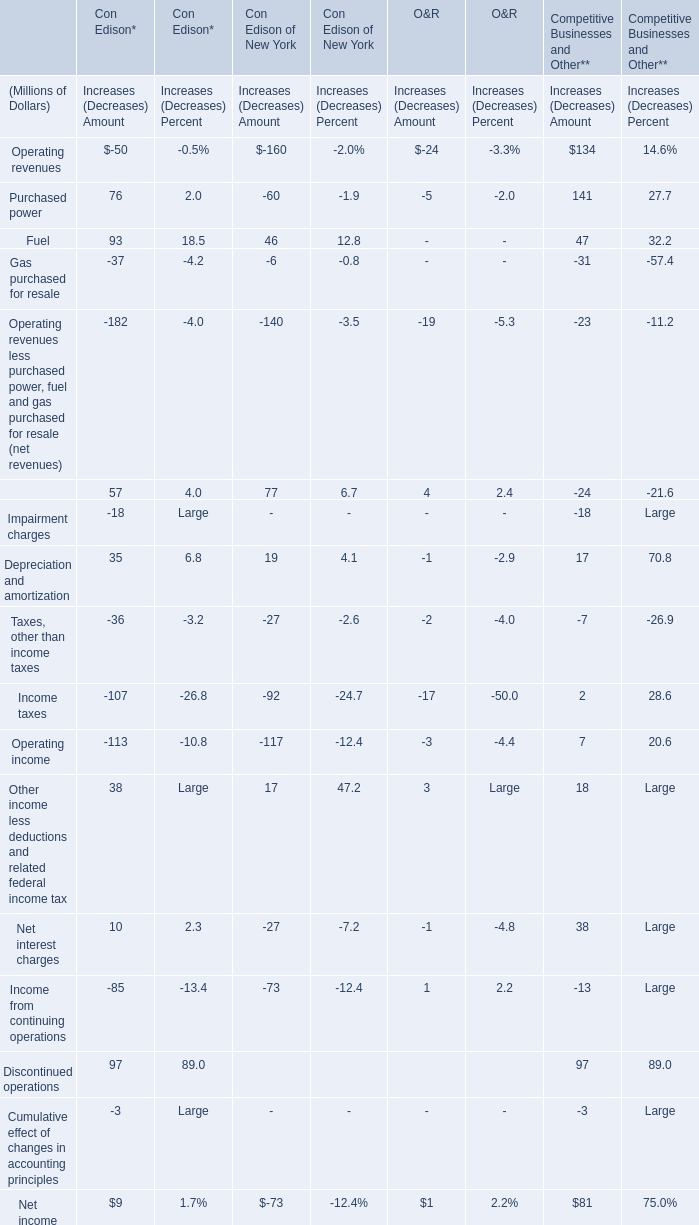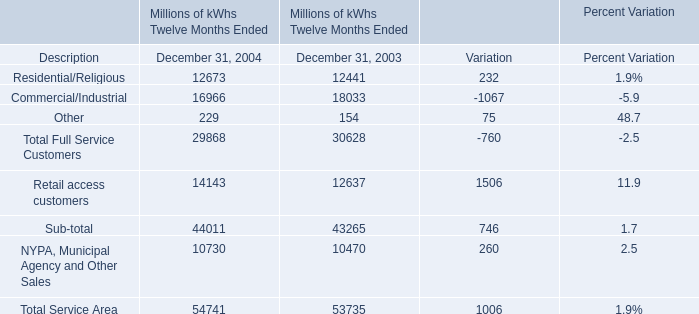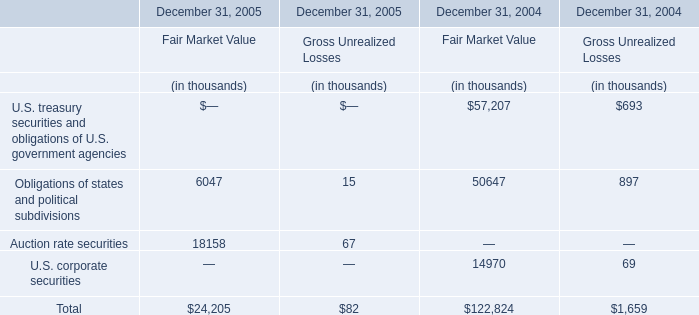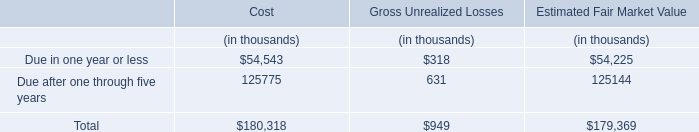In the year with lowest amount of electricity volume of Total Full Service Customers, what's the increasing rate of electricity volume of Total Service Area? 
Computations: ((54741 - 53735) / 53735)
Answer: 0.01872. 